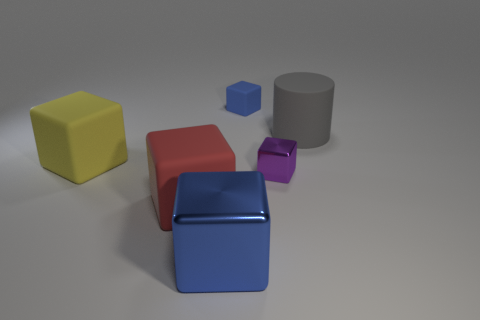Are the blue object that is behind the large matte cylinder and the big gray thing that is behind the yellow rubber cube made of the same material?
Ensure brevity in your answer.  Yes. What number of blue metal cubes are the same size as the gray rubber cylinder?
Your response must be concise. 1. The thing that is the same color as the small rubber cube is what shape?
Provide a succinct answer. Cube. What is the material of the big object that is behind the yellow thing?
Offer a terse response. Rubber. How many other large red things have the same shape as the big metal object?
Give a very brief answer. 1. There is a gray thing that is the same material as the small blue object; what is its shape?
Your answer should be compact. Cylinder. There is a big matte thing that is left of the big matte cube to the right of the large rubber thing that is to the left of the red matte cube; what is its shape?
Your answer should be compact. Cube. Are there more tiny cyan matte spheres than large gray matte cylinders?
Provide a succinct answer. No. There is a large blue object that is the same shape as the purple shiny thing; what material is it?
Ensure brevity in your answer.  Metal. Are the red thing and the yellow block made of the same material?
Your answer should be very brief. Yes. 